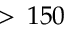Convert formula to latex. <formula><loc_0><loc_0><loc_500><loc_500>> \, 1 5 0</formula> 